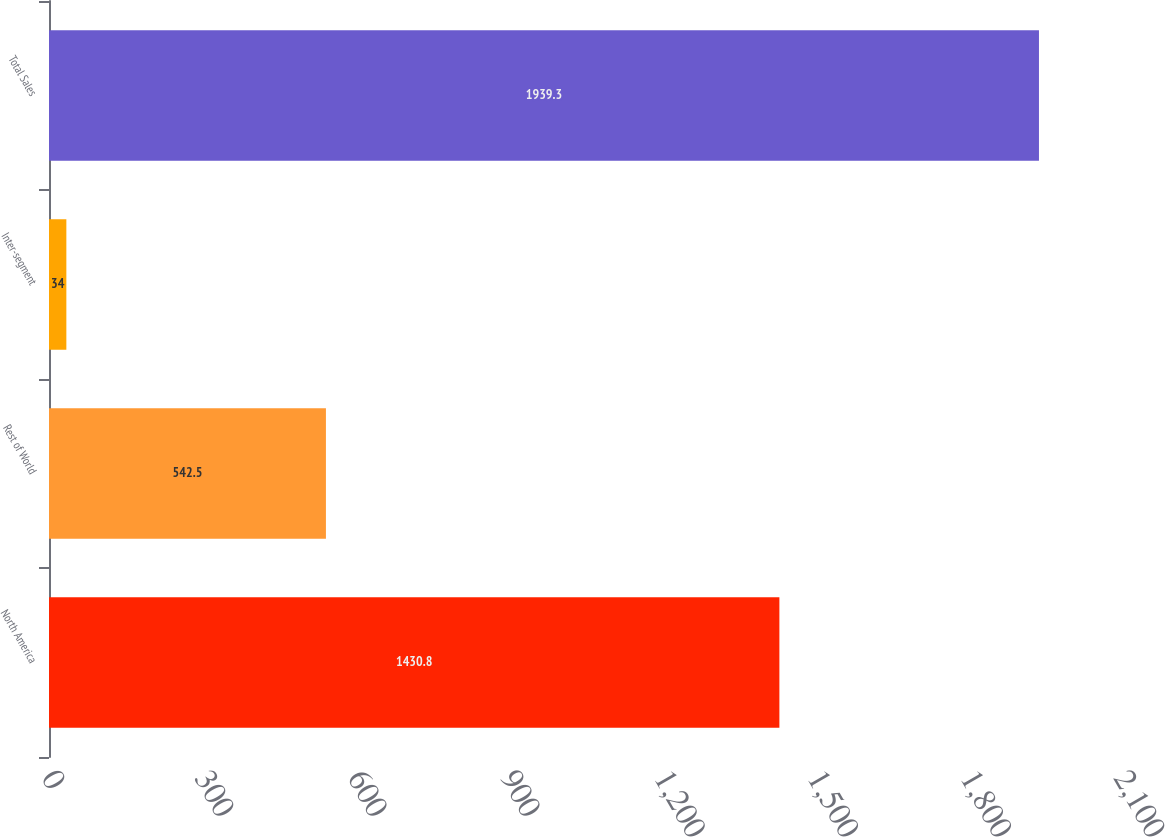<chart> <loc_0><loc_0><loc_500><loc_500><bar_chart><fcel>North America<fcel>Rest of World<fcel>Inter-segment<fcel>Total Sales<nl><fcel>1430.8<fcel>542.5<fcel>34<fcel>1939.3<nl></chart> 